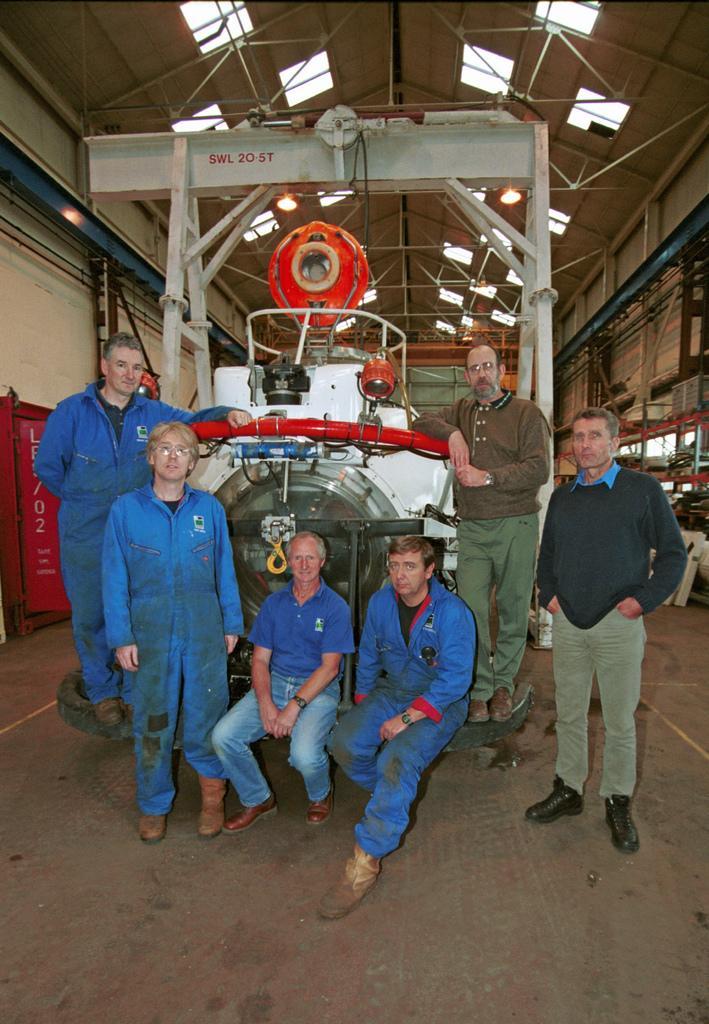Can you describe this image briefly? In this image we can see a machine, some people were standing on the machine and some people were sitting on the machine and one person is standing on the floor, on the top there is a roof with the lights. 